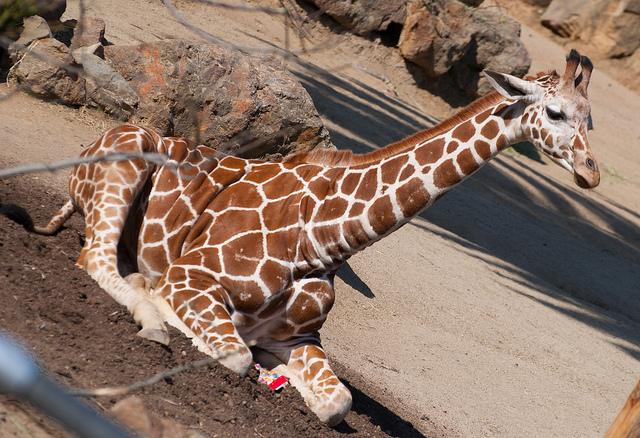Is the animals ears up?
Give a very brief answer. No. Are the animals' whole bodies visible?
Write a very short answer. Yes. What kind of animal is this?
Write a very short answer. Giraffe. Is the giraffe's tongue out?
Quick response, please. No. Where is the giraffe?
Short answer required. Zoo. 